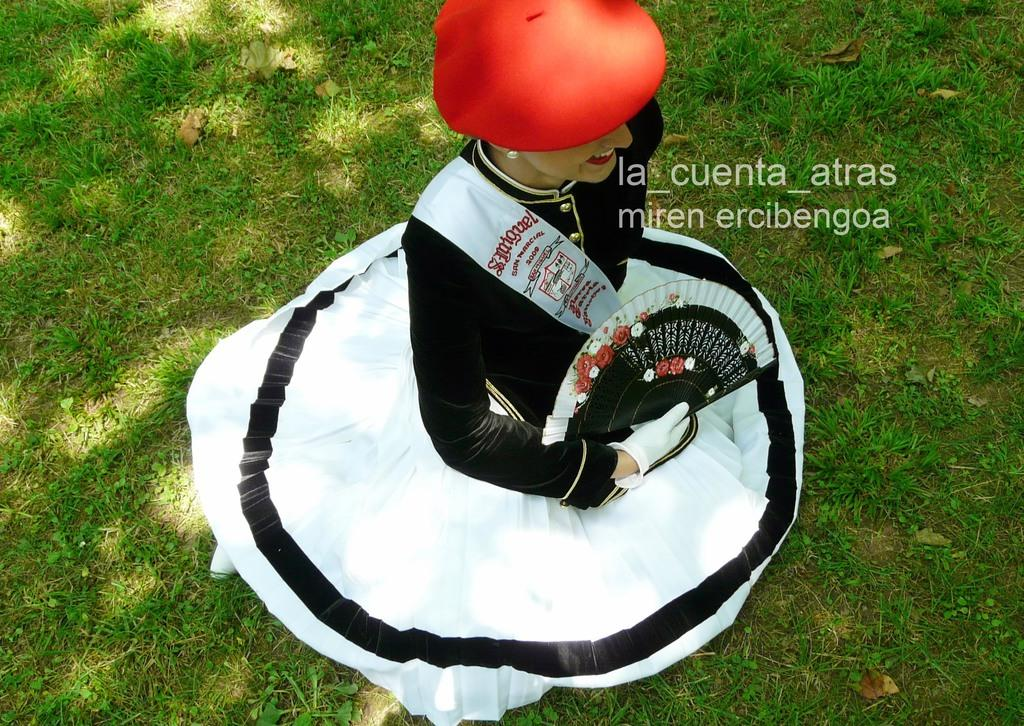Who is the main subject in the image? There is a woman in the image. What is the woman wearing on her head? The woman is wearing a red color hat. Where is the woman sitting in the image? The woman is sitting on the grass. What does the caption say about the woman's uncle in the image? There is no caption present in the image, and therefore no information about the woman's uncle can be determined. 